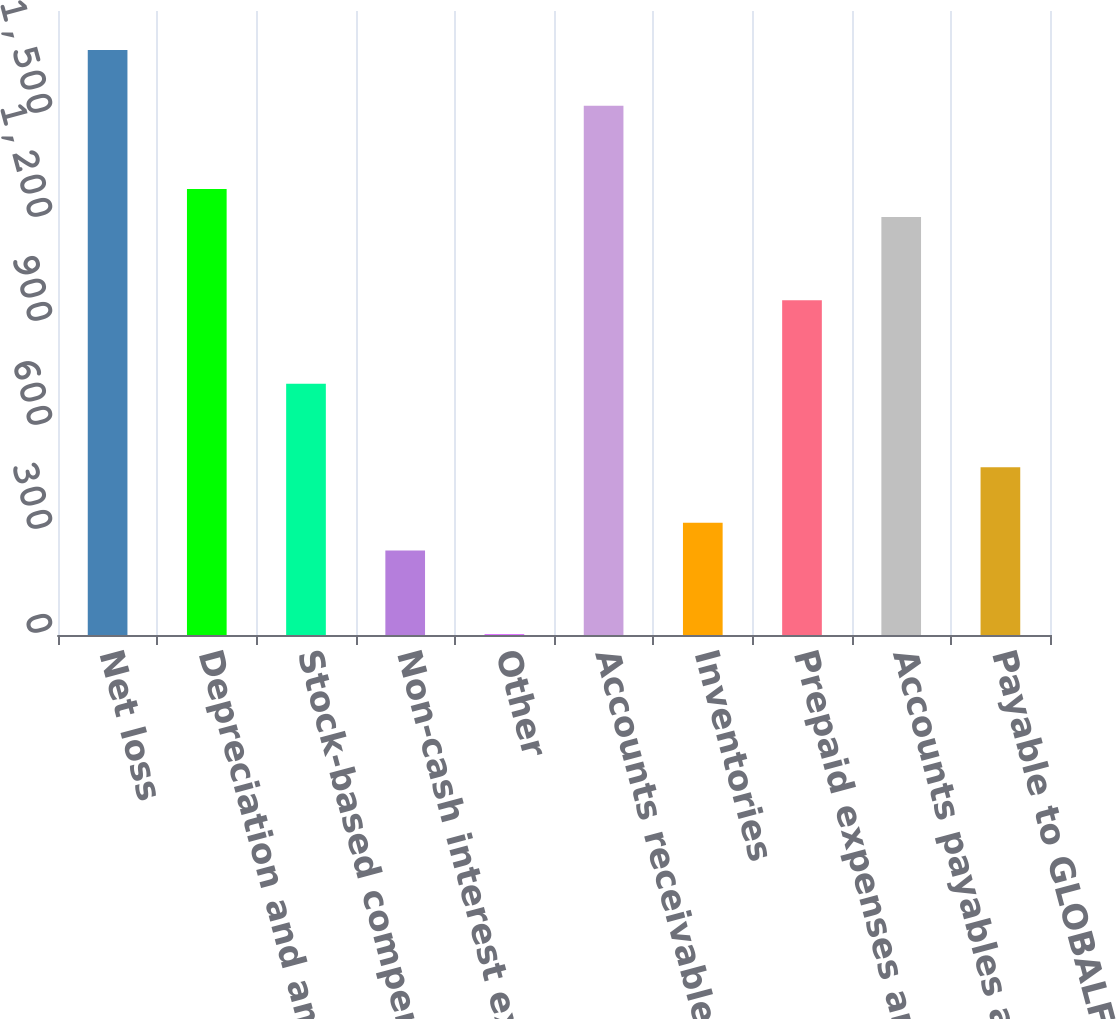Convert chart to OTSL. <chart><loc_0><loc_0><loc_500><loc_500><bar_chart><fcel>Net loss<fcel>Depreciation and amortization<fcel>Stock-based compensation<fcel>Non-cash interest expense<fcel>Other<fcel>Accounts receivable<fcel>Inventories<fcel>Prepaid expenses and other<fcel>Accounts payables accrued<fcel>Payable to GLOBALFOUNDRIES<nl><fcel>1687.2<fcel>1286.2<fcel>724.8<fcel>243.6<fcel>3<fcel>1526.8<fcel>323.8<fcel>965.4<fcel>1206<fcel>484.2<nl></chart> 